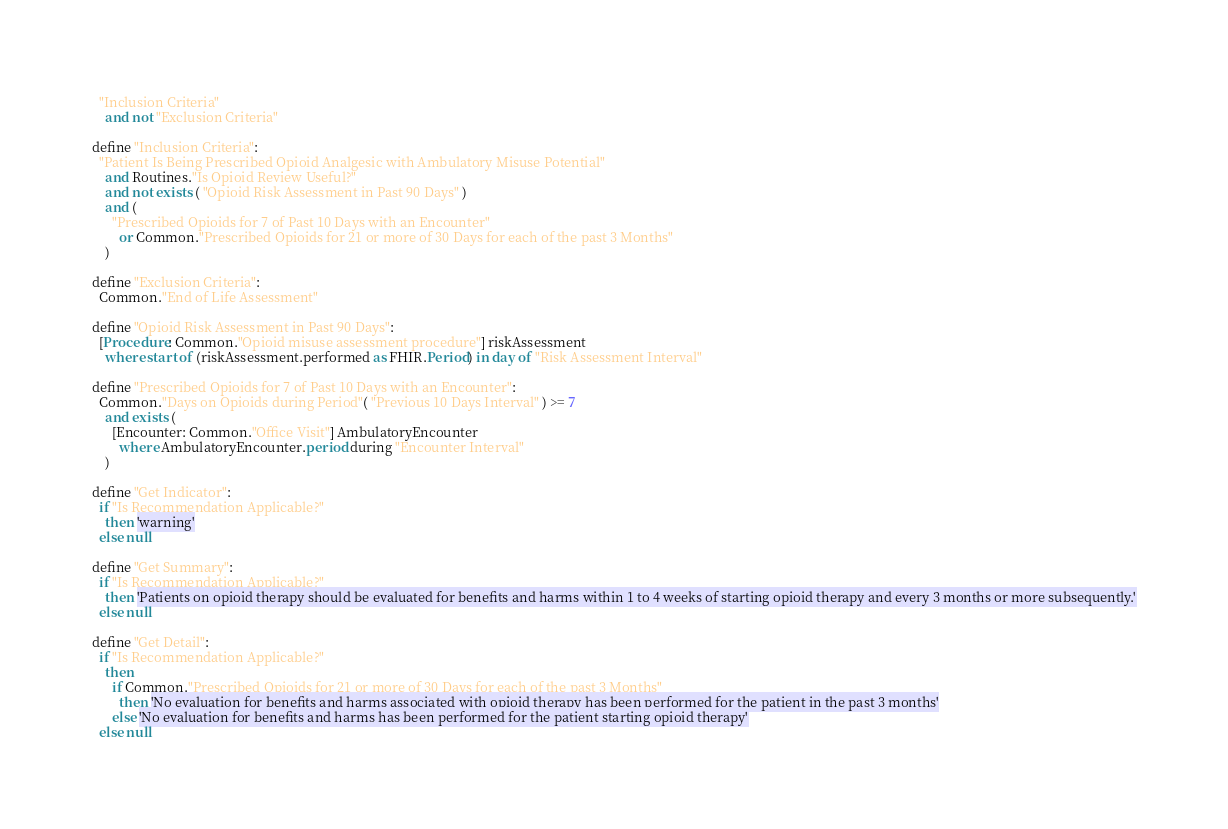<code> <loc_0><loc_0><loc_500><loc_500><_SQL_>  "Inclusion Criteria"
    and not "Exclusion Criteria"

define "Inclusion Criteria":
  "Patient Is Being Prescribed Opioid Analgesic with Ambulatory Misuse Potential"
    and Routines."Is Opioid Review Useful?"
    and not exists ( "Opioid Risk Assessment in Past 90 Days" )
    and (
      "Prescribed Opioids for 7 of Past 10 Days with an Encounter"
        or Common."Prescribed Opioids for 21 or more of 30 Days for each of the past 3 Months"
    )

define "Exclusion Criteria":
  Common."End of Life Assessment"

define "Opioid Risk Assessment in Past 90 Days":
  [Procedure: Common."Opioid misuse assessment procedure"] riskAssessment
    where start of (riskAssessment.performed as FHIR.Period) in day of "Risk Assessment Interval"

define "Prescribed Opioids for 7 of Past 10 Days with an Encounter":
  Common."Days on Opioids during Period"( "Previous 10 Days Interval" ) >= 7
    and exists (
      [Encounter: Common."Office Visit"] AmbulatoryEncounter
        where AmbulatoryEncounter.period during "Encounter Interval"
    )

define "Get Indicator":
  if "Is Recommendation Applicable?"
    then 'warning'
  else null

define "Get Summary":
  if "Is Recommendation Applicable?"
    then 'Patients on opioid therapy should be evaluated for benefits and harms within 1 to 4 weeks of starting opioid therapy and every 3 months or more subsequently.'
  else null

define "Get Detail":
  if "Is Recommendation Applicable?"
    then
      if Common."Prescribed Opioids for 21 or more of 30 Days for each of the past 3 Months"
        then 'No evaluation for benefits and harms associated with opioid therapy has been performed for the patient in the past 3 months'
      else 'No evaluation for benefits and harms has been performed for the patient starting opioid therapy'
  else null
</code> 